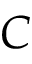<formula> <loc_0><loc_0><loc_500><loc_500>C</formula> 